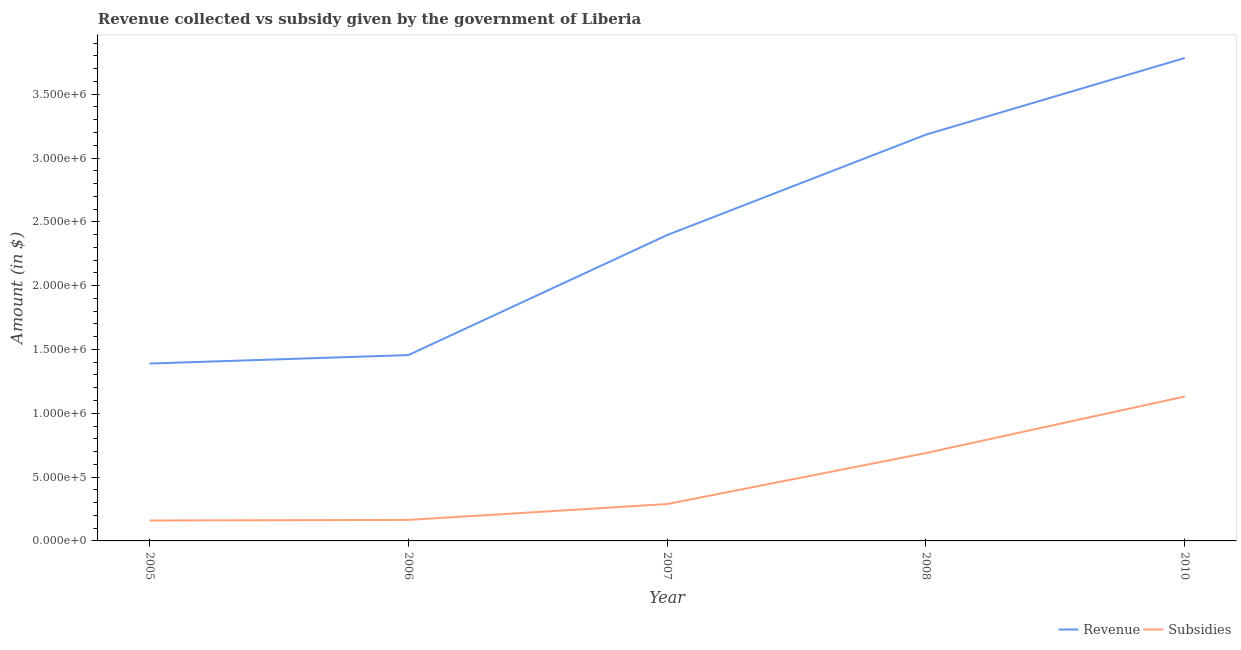How many different coloured lines are there?
Ensure brevity in your answer.  2. What is the amount of subsidies given in 2006?
Your response must be concise. 1.65e+05. Across all years, what is the maximum amount of revenue collected?
Your answer should be very brief. 3.78e+06. Across all years, what is the minimum amount of revenue collected?
Your answer should be very brief. 1.39e+06. In which year was the amount of subsidies given minimum?
Make the answer very short. 2005. What is the total amount of revenue collected in the graph?
Your response must be concise. 1.22e+07. What is the difference between the amount of revenue collected in 2007 and that in 2008?
Your answer should be compact. -7.87e+05. What is the difference between the amount of subsidies given in 2006 and the amount of revenue collected in 2008?
Provide a short and direct response. -3.02e+06. What is the average amount of subsidies given per year?
Keep it short and to the point. 4.87e+05. In the year 2007, what is the difference between the amount of revenue collected and amount of subsidies given?
Provide a short and direct response. 2.11e+06. In how many years, is the amount of subsidies given greater than 3500000 $?
Provide a succinct answer. 0. What is the ratio of the amount of subsidies given in 2006 to that in 2008?
Give a very brief answer. 0.24. What is the difference between the highest and the second highest amount of subsidies given?
Ensure brevity in your answer.  4.43e+05. What is the difference between the highest and the lowest amount of revenue collected?
Your answer should be very brief. 2.39e+06. In how many years, is the amount of revenue collected greater than the average amount of revenue collected taken over all years?
Give a very brief answer. 2. Is the sum of the amount of subsidies given in 2006 and 2008 greater than the maximum amount of revenue collected across all years?
Give a very brief answer. No. How many lines are there?
Your response must be concise. 2. How many years are there in the graph?
Give a very brief answer. 5. What is the difference between two consecutive major ticks on the Y-axis?
Offer a very short reply. 5.00e+05. Are the values on the major ticks of Y-axis written in scientific E-notation?
Provide a succinct answer. Yes. Does the graph contain any zero values?
Ensure brevity in your answer.  No. Where does the legend appear in the graph?
Keep it short and to the point. Bottom right. How many legend labels are there?
Make the answer very short. 2. What is the title of the graph?
Your answer should be compact. Revenue collected vs subsidy given by the government of Liberia. Does "Time to export" appear as one of the legend labels in the graph?
Your answer should be compact. No. What is the label or title of the Y-axis?
Keep it short and to the point. Amount (in $). What is the Amount (in $) in Revenue in 2005?
Your answer should be very brief. 1.39e+06. What is the Amount (in $) in Subsidies in 2005?
Your response must be concise. 1.60e+05. What is the Amount (in $) in Revenue in 2006?
Your response must be concise. 1.46e+06. What is the Amount (in $) in Subsidies in 2006?
Your response must be concise. 1.65e+05. What is the Amount (in $) in Revenue in 2007?
Your answer should be very brief. 2.40e+06. What is the Amount (in $) of Subsidies in 2007?
Give a very brief answer. 2.89e+05. What is the Amount (in $) of Revenue in 2008?
Your answer should be very brief. 3.18e+06. What is the Amount (in $) of Subsidies in 2008?
Give a very brief answer. 6.89e+05. What is the Amount (in $) in Revenue in 2010?
Make the answer very short. 3.78e+06. What is the Amount (in $) of Subsidies in 2010?
Provide a succinct answer. 1.13e+06. Across all years, what is the maximum Amount (in $) of Revenue?
Make the answer very short. 3.78e+06. Across all years, what is the maximum Amount (in $) in Subsidies?
Your response must be concise. 1.13e+06. Across all years, what is the minimum Amount (in $) of Revenue?
Offer a very short reply. 1.39e+06. Across all years, what is the minimum Amount (in $) in Subsidies?
Keep it short and to the point. 1.60e+05. What is the total Amount (in $) of Revenue in the graph?
Your answer should be very brief. 1.22e+07. What is the total Amount (in $) of Subsidies in the graph?
Offer a very short reply. 2.43e+06. What is the difference between the Amount (in $) of Revenue in 2005 and that in 2006?
Ensure brevity in your answer.  -6.64e+04. What is the difference between the Amount (in $) of Subsidies in 2005 and that in 2006?
Make the answer very short. -4671.72. What is the difference between the Amount (in $) of Revenue in 2005 and that in 2007?
Ensure brevity in your answer.  -1.01e+06. What is the difference between the Amount (in $) of Subsidies in 2005 and that in 2007?
Provide a short and direct response. -1.29e+05. What is the difference between the Amount (in $) in Revenue in 2005 and that in 2008?
Your answer should be compact. -1.79e+06. What is the difference between the Amount (in $) of Subsidies in 2005 and that in 2008?
Provide a succinct answer. -5.29e+05. What is the difference between the Amount (in $) of Revenue in 2005 and that in 2010?
Make the answer very short. -2.39e+06. What is the difference between the Amount (in $) in Subsidies in 2005 and that in 2010?
Ensure brevity in your answer.  -9.71e+05. What is the difference between the Amount (in $) in Revenue in 2006 and that in 2007?
Your response must be concise. -9.40e+05. What is the difference between the Amount (in $) in Subsidies in 2006 and that in 2007?
Ensure brevity in your answer.  -1.24e+05. What is the difference between the Amount (in $) of Revenue in 2006 and that in 2008?
Provide a succinct answer. -1.73e+06. What is the difference between the Amount (in $) in Subsidies in 2006 and that in 2008?
Your answer should be compact. -5.24e+05. What is the difference between the Amount (in $) in Revenue in 2006 and that in 2010?
Provide a succinct answer. -2.33e+06. What is the difference between the Amount (in $) of Subsidies in 2006 and that in 2010?
Make the answer very short. -9.67e+05. What is the difference between the Amount (in $) in Revenue in 2007 and that in 2008?
Your answer should be very brief. -7.87e+05. What is the difference between the Amount (in $) in Subsidies in 2007 and that in 2008?
Your answer should be compact. -4.00e+05. What is the difference between the Amount (in $) in Revenue in 2007 and that in 2010?
Ensure brevity in your answer.  -1.39e+06. What is the difference between the Amount (in $) of Subsidies in 2007 and that in 2010?
Provide a succinct answer. -8.42e+05. What is the difference between the Amount (in $) of Revenue in 2008 and that in 2010?
Provide a succinct answer. -6.00e+05. What is the difference between the Amount (in $) in Subsidies in 2008 and that in 2010?
Your answer should be compact. -4.43e+05. What is the difference between the Amount (in $) in Revenue in 2005 and the Amount (in $) in Subsidies in 2006?
Offer a very short reply. 1.23e+06. What is the difference between the Amount (in $) in Revenue in 2005 and the Amount (in $) in Subsidies in 2007?
Provide a short and direct response. 1.10e+06. What is the difference between the Amount (in $) in Revenue in 2005 and the Amount (in $) in Subsidies in 2008?
Make the answer very short. 7.01e+05. What is the difference between the Amount (in $) of Revenue in 2005 and the Amount (in $) of Subsidies in 2010?
Ensure brevity in your answer.  2.58e+05. What is the difference between the Amount (in $) in Revenue in 2006 and the Amount (in $) in Subsidies in 2007?
Keep it short and to the point. 1.17e+06. What is the difference between the Amount (in $) of Revenue in 2006 and the Amount (in $) of Subsidies in 2008?
Give a very brief answer. 7.67e+05. What is the difference between the Amount (in $) in Revenue in 2006 and the Amount (in $) in Subsidies in 2010?
Offer a very short reply. 3.25e+05. What is the difference between the Amount (in $) of Revenue in 2007 and the Amount (in $) of Subsidies in 2008?
Offer a very short reply. 1.71e+06. What is the difference between the Amount (in $) of Revenue in 2007 and the Amount (in $) of Subsidies in 2010?
Provide a short and direct response. 1.27e+06. What is the difference between the Amount (in $) in Revenue in 2008 and the Amount (in $) in Subsidies in 2010?
Make the answer very short. 2.05e+06. What is the average Amount (in $) in Revenue per year?
Offer a terse response. 2.44e+06. What is the average Amount (in $) in Subsidies per year?
Provide a short and direct response. 4.87e+05. In the year 2005, what is the difference between the Amount (in $) of Revenue and Amount (in $) of Subsidies?
Your answer should be very brief. 1.23e+06. In the year 2006, what is the difference between the Amount (in $) in Revenue and Amount (in $) in Subsidies?
Provide a succinct answer. 1.29e+06. In the year 2007, what is the difference between the Amount (in $) of Revenue and Amount (in $) of Subsidies?
Provide a succinct answer. 2.11e+06. In the year 2008, what is the difference between the Amount (in $) in Revenue and Amount (in $) in Subsidies?
Give a very brief answer. 2.49e+06. In the year 2010, what is the difference between the Amount (in $) of Revenue and Amount (in $) of Subsidies?
Your answer should be very brief. 2.65e+06. What is the ratio of the Amount (in $) in Revenue in 2005 to that in 2006?
Offer a terse response. 0.95. What is the ratio of the Amount (in $) in Subsidies in 2005 to that in 2006?
Your answer should be compact. 0.97. What is the ratio of the Amount (in $) in Revenue in 2005 to that in 2007?
Your answer should be compact. 0.58. What is the ratio of the Amount (in $) of Subsidies in 2005 to that in 2007?
Offer a terse response. 0.55. What is the ratio of the Amount (in $) of Revenue in 2005 to that in 2008?
Offer a terse response. 0.44. What is the ratio of the Amount (in $) in Subsidies in 2005 to that in 2008?
Offer a terse response. 0.23. What is the ratio of the Amount (in $) of Revenue in 2005 to that in 2010?
Your response must be concise. 0.37. What is the ratio of the Amount (in $) of Subsidies in 2005 to that in 2010?
Your response must be concise. 0.14. What is the ratio of the Amount (in $) of Revenue in 2006 to that in 2007?
Provide a succinct answer. 0.61. What is the ratio of the Amount (in $) in Subsidies in 2006 to that in 2007?
Offer a very short reply. 0.57. What is the ratio of the Amount (in $) of Revenue in 2006 to that in 2008?
Offer a very short reply. 0.46. What is the ratio of the Amount (in $) in Subsidies in 2006 to that in 2008?
Ensure brevity in your answer.  0.24. What is the ratio of the Amount (in $) in Revenue in 2006 to that in 2010?
Offer a terse response. 0.38. What is the ratio of the Amount (in $) in Subsidies in 2006 to that in 2010?
Ensure brevity in your answer.  0.15. What is the ratio of the Amount (in $) of Revenue in 2007 to that in 2008?
Provide a short and direct response. 0.75. What is the ratio of the Amount (in $) in Subsidies in 2007 to that in 2008?
Offer a very short reply. 0.42. What is the ratio of the Amount (in $) of Revenue in 2007 to that in 2010?
Provide a short and direct response. 0.63. What is the ratio of the Amount (in $) of Subsidies in 2007 to that in 2010?
Ensure brevity in your answer.  0.26. What is the ratio of the Amount (in $) of Revenue in 2008 to that in 2010?
Ensure brevity in your answer.  0.84. What is the ratio of the Amount (in $) of Subsidies in 2008 to that in 2010?
Give a very brief answer. 0.61. What is the difference between the highest and the second highest Amount (in $) of Revenue?
Offer a terse response. 6.00e+05. What is the difference between the highest and the second highest Amount (in $) of Subsidies?
Ensure brevity in your answer.  4.43e+05. What is the difference between the highest and the lowest Amount (in $) of Revenue?
Give a very brief answer. 2.39e+06. What is the difference between the highest and the lowest Amount (in $) in Subsidies?
Offer a terse response. 9.71e+05. 